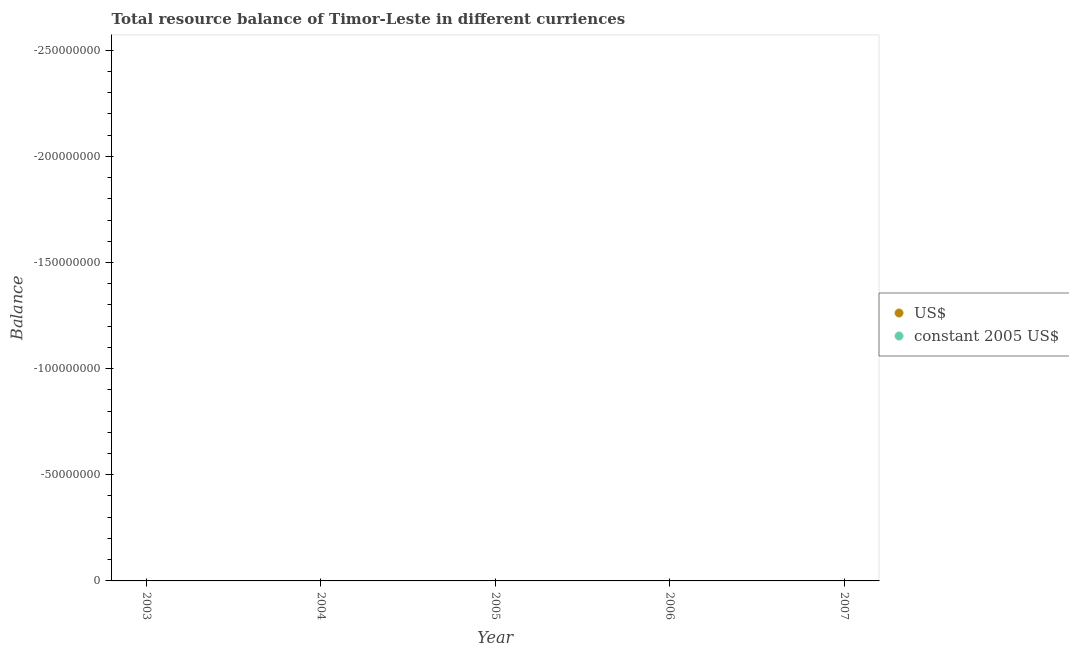What is the resource balance in us$ in 2003?
Make the answer very short. 0. Across all years, what is the minimum resource balance in us$?
Offer a terse response. 0. What is the total resource balance in constant us$ in the graph?
Offer a terse response. 0. In how many years, is the resource balance in constant us$ greater than -10000000 units?
Offer a very short reply. 0. In how many years, is the resource balance in constant us$ greater than the average resource balance in constant us$ taken over all years?
Ensure brevity in your answer.  0. Is the resource balance in constant us$ strictly less than the resource balance in us$ over the years?
Your answer should be compact. No. How many years are there in the graph?
Provide a short and direct response. 5. What is the difference between two consecutive major ticks on the Y-axis?
Your answer should be compact. 5.00e+07. Are the values on the major ticks of Y-axis written in scientific E-notation?
Ensure brevity in your answer.  No. Does the graph contain any zero values?
Your response must be concise. Yes. Where does the legend appear in the graph?
Offer a terse response. Center right. How are the legend labels stacked?
Make the answer very short. Vertical. What is the title of the graph?
Give a very brief answer. Total resource balance of Timor-Leste in different curriences. Does "Net savings(excluding particulate emission damage)" appear as one of the legend labels in the graph?
Your response must be concise. No. What is the label or title of the Y-axis?
Make the answer very short. Balance. What is the Balance in US$ in 2003?
Offer a terse response. 0. What is the Balance in constant 2005 US$ in 2003?
Your answer should be very brief. 0. What is the Balance of US$ in 2005?
Offer a terse response. 0. What is the Balance in constant 2005 US$ in 2005?
Keep it short and to the point. 0. What is the Balance of US$ in 2006?
Your response must be concise. 0. What is the Balance in constant 2005 US$ in 2006?
Your response must be concise. 0. What is the Balance of US$ in 2007?
Make the answer very short. 0. What is the total Balance of constant 2005 US$ in the graph?
Your answer should be compact. 0. 